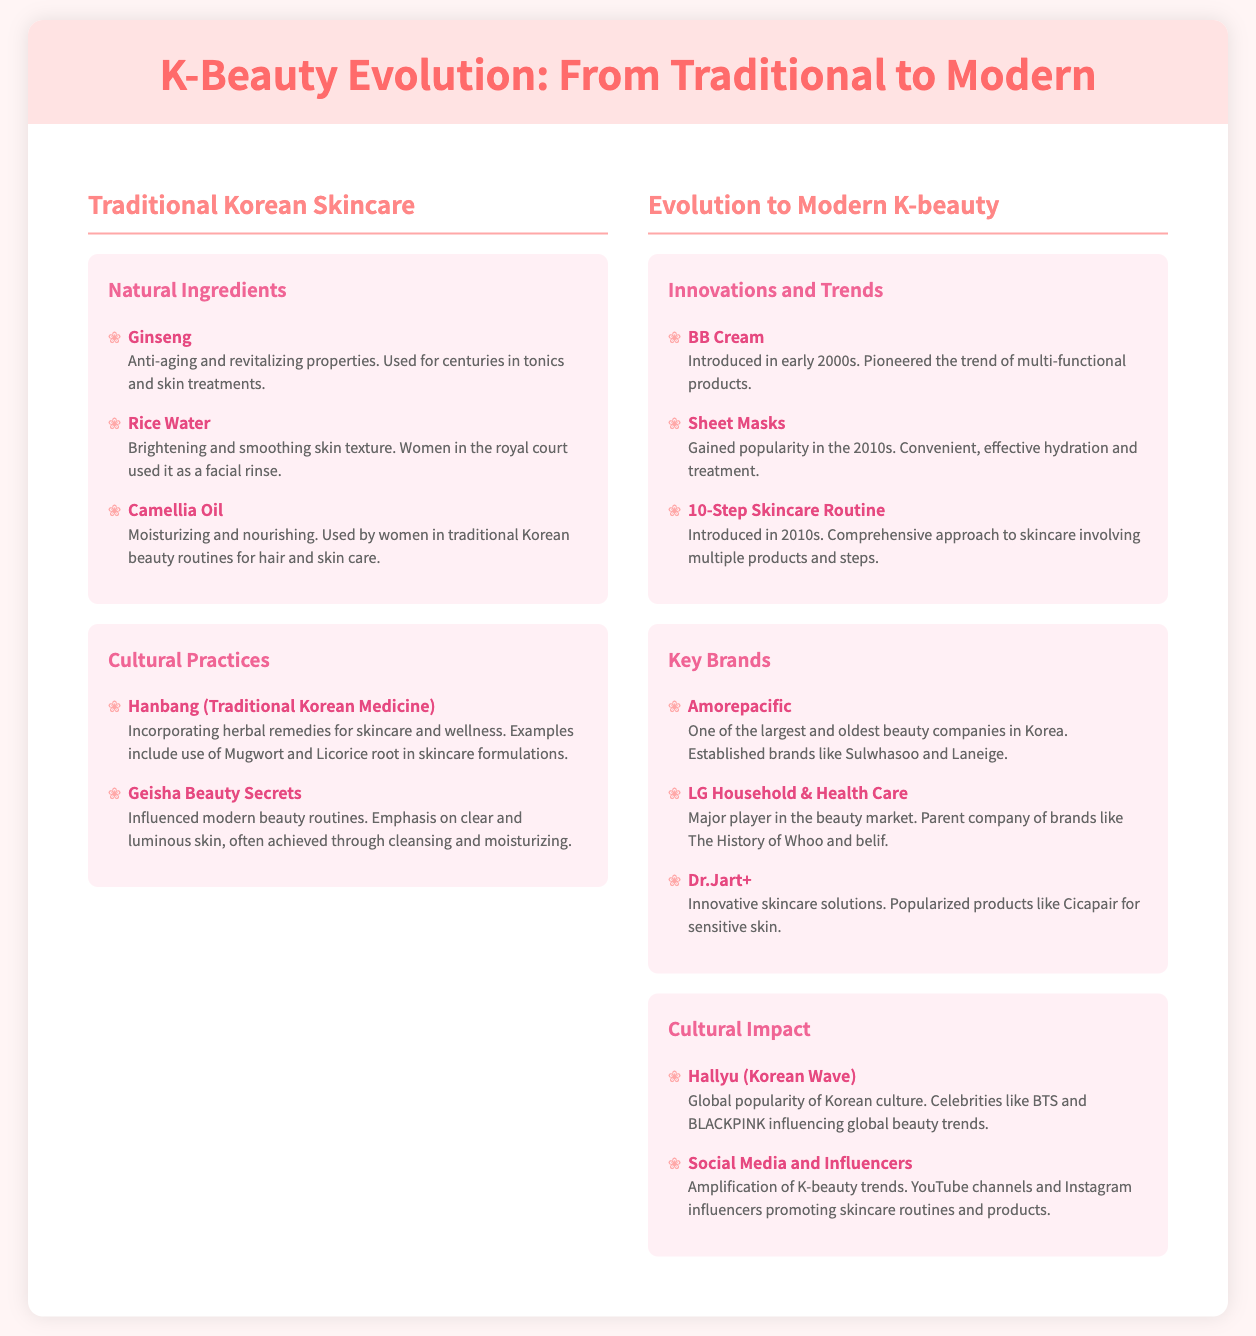What is the first category listed under Traditional Korean Skincare? The first category is "Natural Ingredients," which is part of Traditional Korean Skincare in the document.
Answer: Natural Ingredients What traditional ingredient is noted for its anti-aging properties? Ginseng is highlighted for its anti-aging and revitalizing properties in the category of Natural Ingredients.
Answer: Ginseng What multifaceted product was introduced in the early 2000s? The document mentions the introduction of BB Cream as a trend in multifunctional products.
Answer: BB Cream Which Korean skincare technique emphasizes multiple steps and was introduced in the 2010s? The 10-Step Skincare Routine is specifically mentioned as a comprehensive approach to skincare introduced in the 2010s.
Answer: 10-Step Skincare Routine Who is one of the largest and oldest beauty companies in Korea? Amorepacific is identified as one of the largest and oldest beauty companies in Korea within the document.
Answer: Amorepacific What cultural phenomenon is driving global popularity for Korean beauty trends? The document states that Hallyu, or the Korean Wave, is the phenomenon influencing global beauty trends.
Answer: Hallyu What has amplified K-beauty trends according to the document? Social Media and Influencers have played a significant role in amplifying K-beauty trends as noted in the Cultural Impact section.
Answer: Social Media and Influencers Which ingredient used in traditional skincare is known for its brightening properties? Rice Water is highlighted for its brightening and smoothing skin texture.
Answer: Rice Water What popular product gained traction in the 2010s for convenient hydration? Sheet Masks are noted for gaining popularity in the 2010s for convenient and effective hydration.
Answer: Sheet Masks 